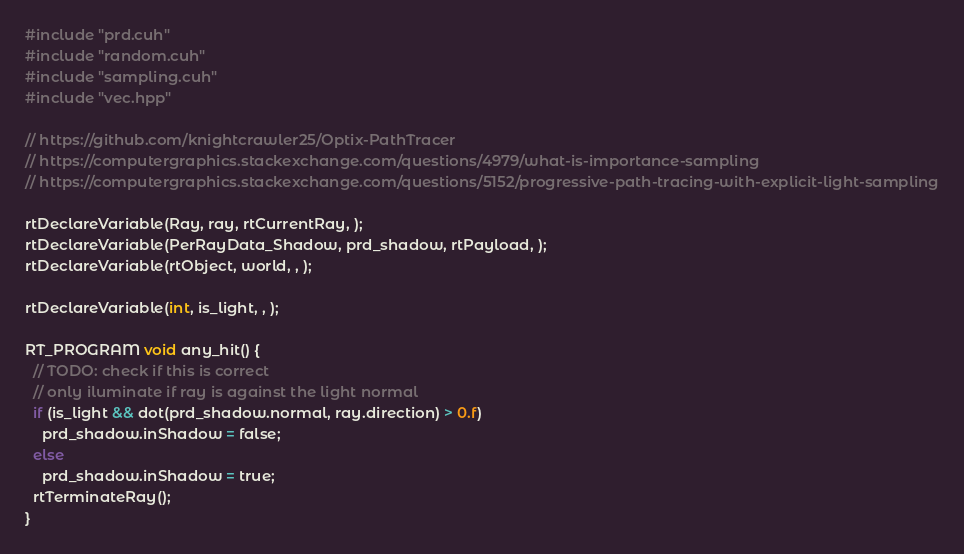Convert code to text. <code><loc_0><loc_0><loc_500><loc_500><_Cuda_>#include "prd.cuh"
#include "random.cuh"
#include "sampling.cuh"
#include "vec.hpp"

// https://github.com/knightcrawler25/Optix-PathTracer
// https://computergraphics.stackexchange.com/questions/4979/what-is-importance-sampling
// https://computergraphics.stackexchange.com/questions/5152/progressive-path-tracing-with-explicit-light-sampling

rtDeclareVariable(Ray, ray, rtCurrentRay, );
rtDeclareVariable(PerRayData_Shadow, prd_shadow, rtPayload, );
rtDeclareVariable(rtObject, world, , );

rtDeclareVariable(int, is_light, , );

RT_PROGRAM void any_hit() {
  // TODO: check if this is correct
  // only iluminate if ray is against the light normal
  if (is_light && dot(prd_shadow.normal, ray.direction) > 0.f)
    prd_shadow.inShadow = false;
  else
    prd_shadow.inShadow = true;
  rtTerminateRay();
}</code> 